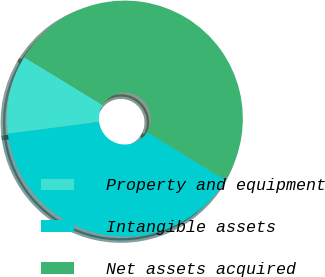Convert chart to OTSL. <chart><loc_0><loc_0><loc_500><loc_500><pie_chart><fcel>Property and equipment<fcel>Intangible assets<fcel>Net assets acquired<nl><fcel>10.77%<fcel>39.23%<fcel>50.0%<nl></chart> 